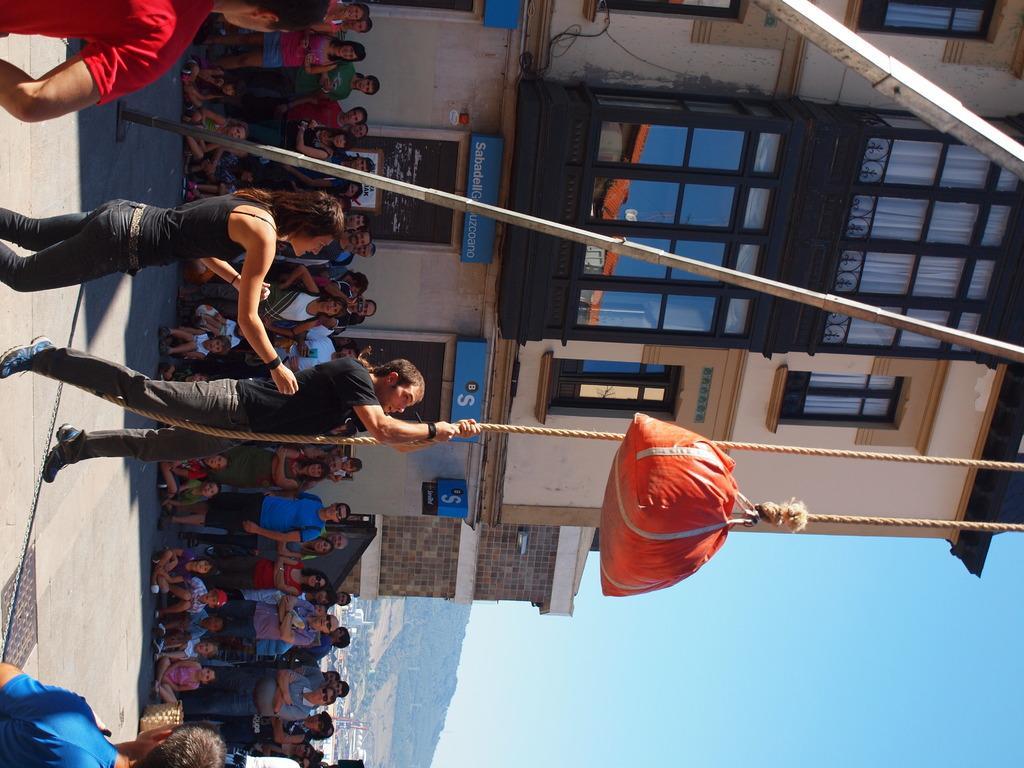Describe this image in one or two sentences. In this picture we can see a man in the black t shirt is holding a rope and to the rope there is an orange object. Behind the man there are poles, some people are sitting and some people are standing on the road. Behind the people there are buildings, a hill and the sky. On the road, it looks like a manhole lid. 